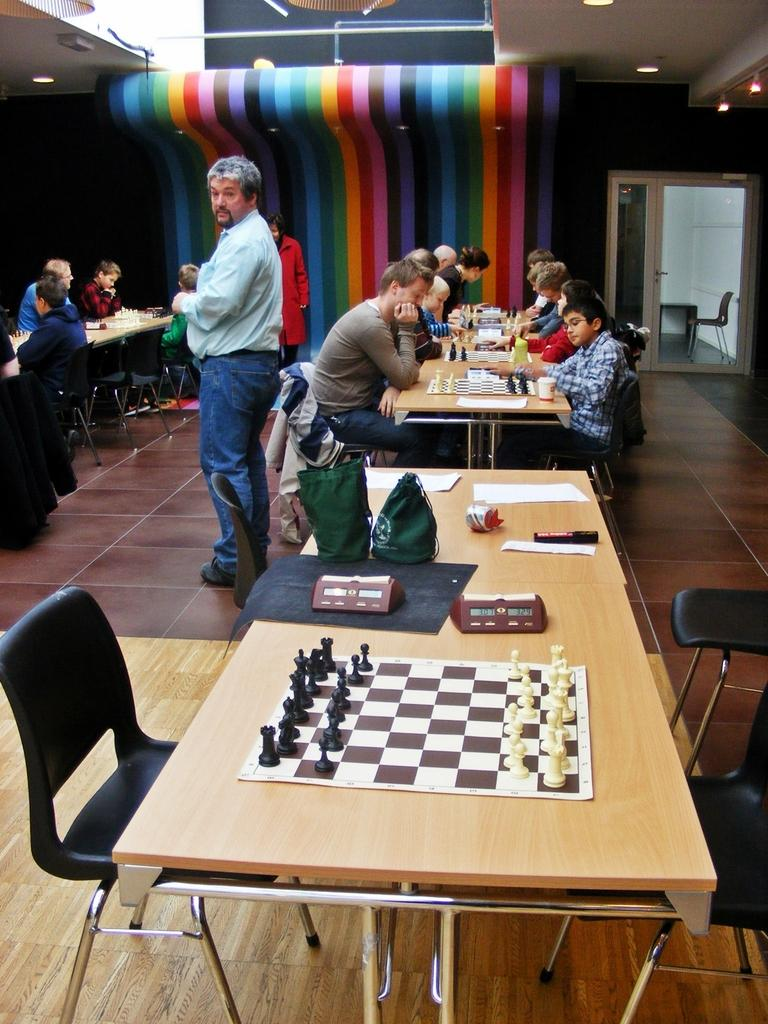What are the people in the image doing? The people in the image are sitting on chairs. What can be seen in the background of the image? There is a door in the image. What is on the table in the image? There is a chess board, coins, and papers on the table. What is the purpose of the chess board? The chess board is used for playing the game of chess. What type of sail can be seen in the image? There is no sail present in the image. Is there any driving activity taking place in the image? There is no driving activity present in the image. 